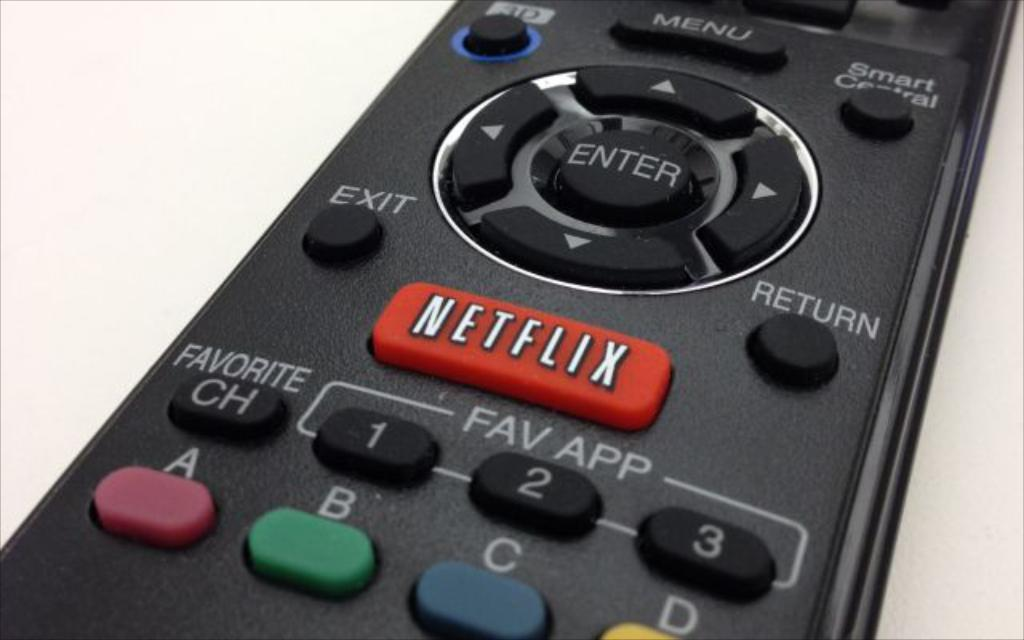<image>
Write a terse but informative summary of the picture. A remote control  with a Netflix button above the Fav app buttons. 